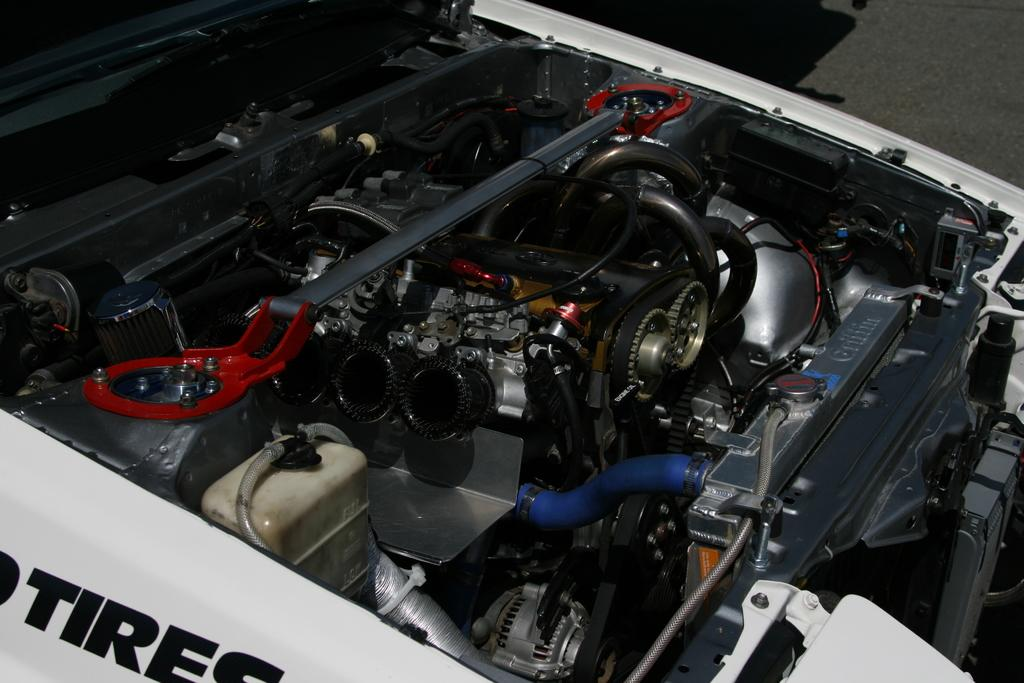What is the main subject of the image? The main subject of the image is a car engine. What specific components can be seen in the car engine? The car engine has pipes and a battery. What type of dirt can be seen covering the car engine in the image? There is no dirt visible on the car engine in the image. How does the sun affect the performance of the car engine in the image? The image does not provide any information about the sun or its effect on the car engine's performance. 